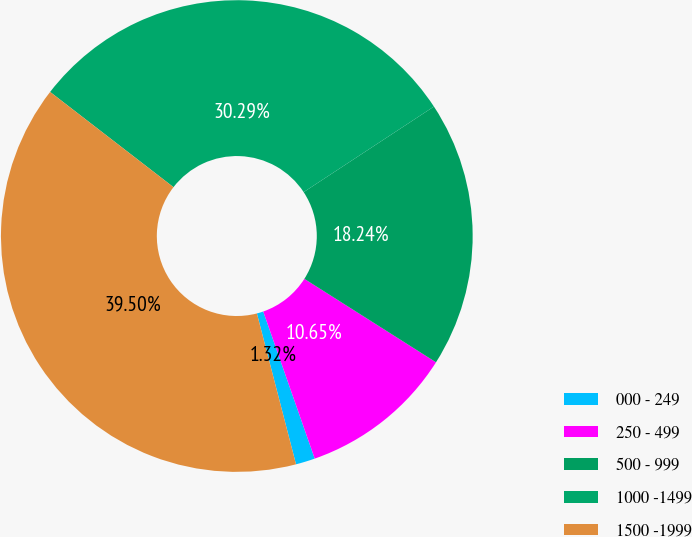Convert chart. <chart><loc_0><loc_0><loc_500><loc_500><pie_chart><fcel>000 - 249<fcel>250 - 499<fcel>500 - 999<fcel>1000 -1499<fcel>1500 -1999<nl><fcel>1.32%<fcel>10.65%<fcel>18.24%<fcel>30.29%<fcel>39.5%<nl></chart> 